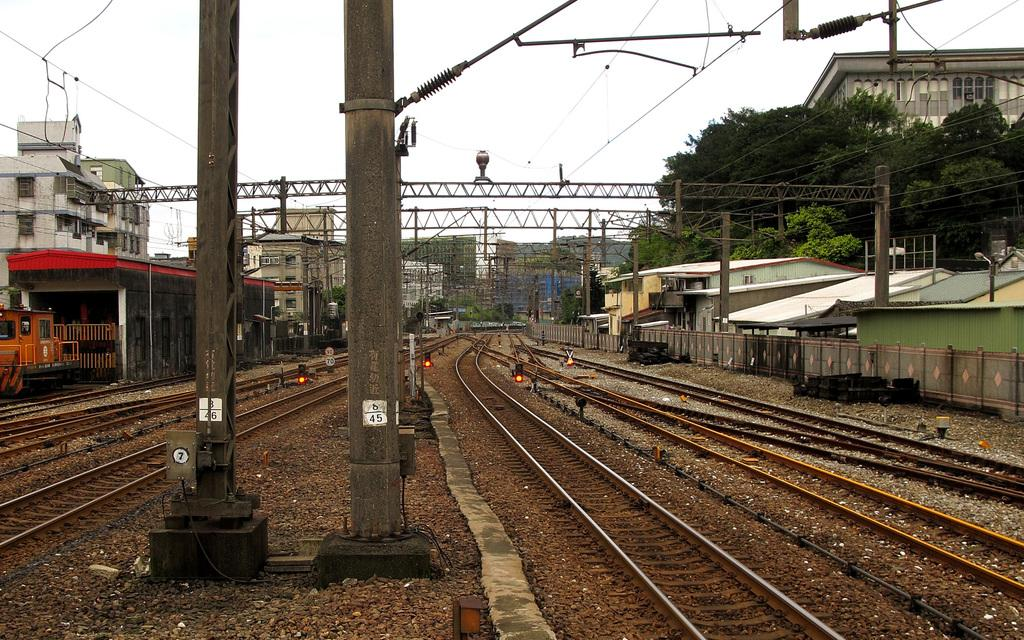What type of transportation infrastructure is visible in the image? There are railway tracks in the image. What structures support the railway tracks? There are pillars in the image. What type of security feature is present in the image? There are iron grills in the image. What type of utility infrastructure is present in the image? There are electric cables in the image. What type of shelter is present in the image? There are sheds in the image. What type of barrier is present in the image? There are fences in the image. What type of vehicle is present in the image? There is a railway engine in the image. What type of built environment is present in the image? There are buildings in the image. What type of natural environment is present in the image? There are trees in the image. What part of the natural environment is visible in the image? The sky is visible in the image. What type of bread is being used to build the railway tracks in the image? There is no bread present in the image, and the railway tracks are not being built with bread. What type of wood is being used to construct the buildings in the image? There is no wood visible in the image, and the buildings are not being constructed with wood. 